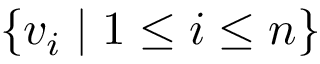<formula> <loc_0><loc_0><loc_500><loc_500>\{ v _ { i } | 1 \leq i \leq n \}</formula> 